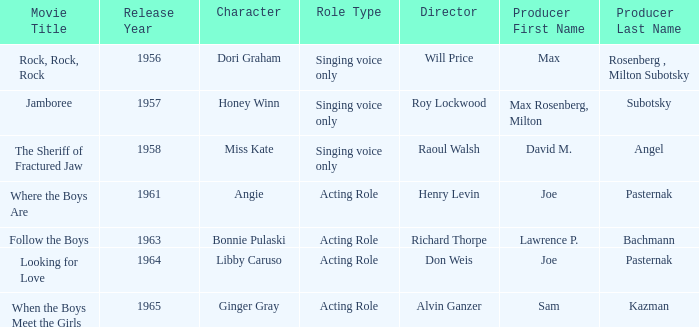What year was Sam Kazman a producer? 1965.0. 